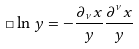Convert formula to latex. <formula><loc_0><loc_0><loc_500><loc_500>\Box \ln { y } = - \frac { \partial _ { \nu } { x } } { y } \frac { \partial ^ { \nu } { x } } { y }</formula> 